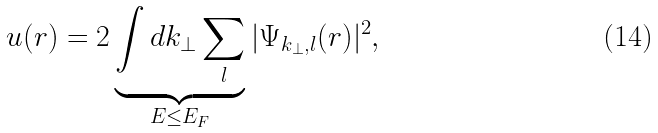Convert formula to latex. <formula><loc_0><loc_0><loc_500><loc_500>u ( { r } ) = { 2 } \underbrace { \int d { k _ { \perp } } \sum _ { l } } _ { E \leq E _ { F } } | \Psi _ { { k _ { \perp } } , l } ( { r } ) | ^ { 2 } ,</formula> 